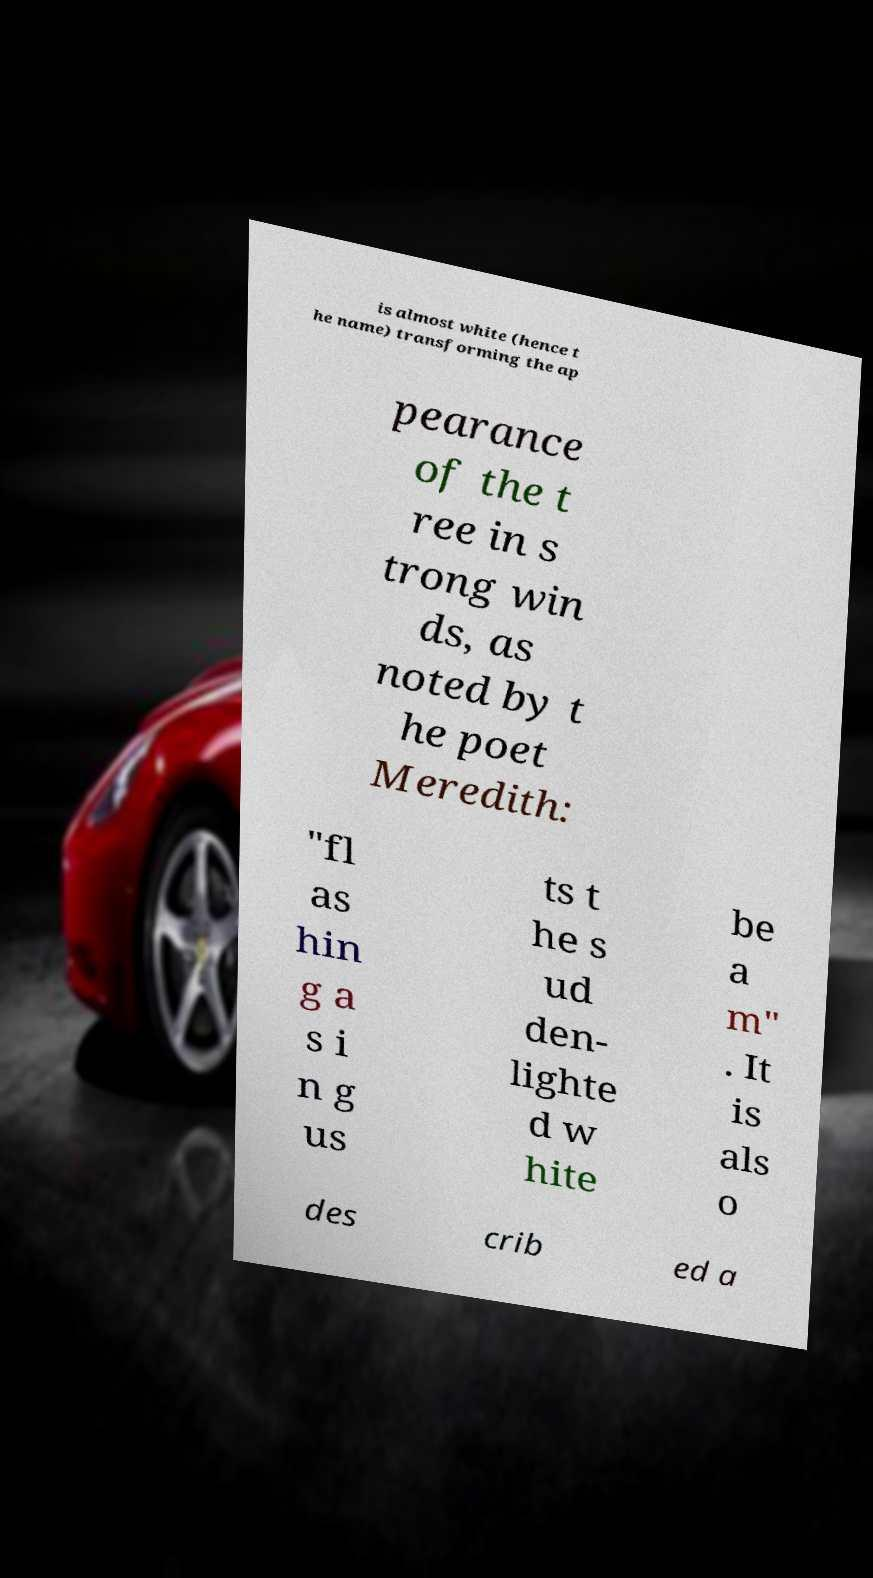Could you assist in decoding the text presented in this image and type it out clearly? is almost white (hence t he name) transforming the ap pearance of the t ree in s trong win ds, as noted by t he poet Meredith: "fl as hin g a s i n g us ts t he s ud den- lighte d w hite be a m" . It is als o des crib ed a 